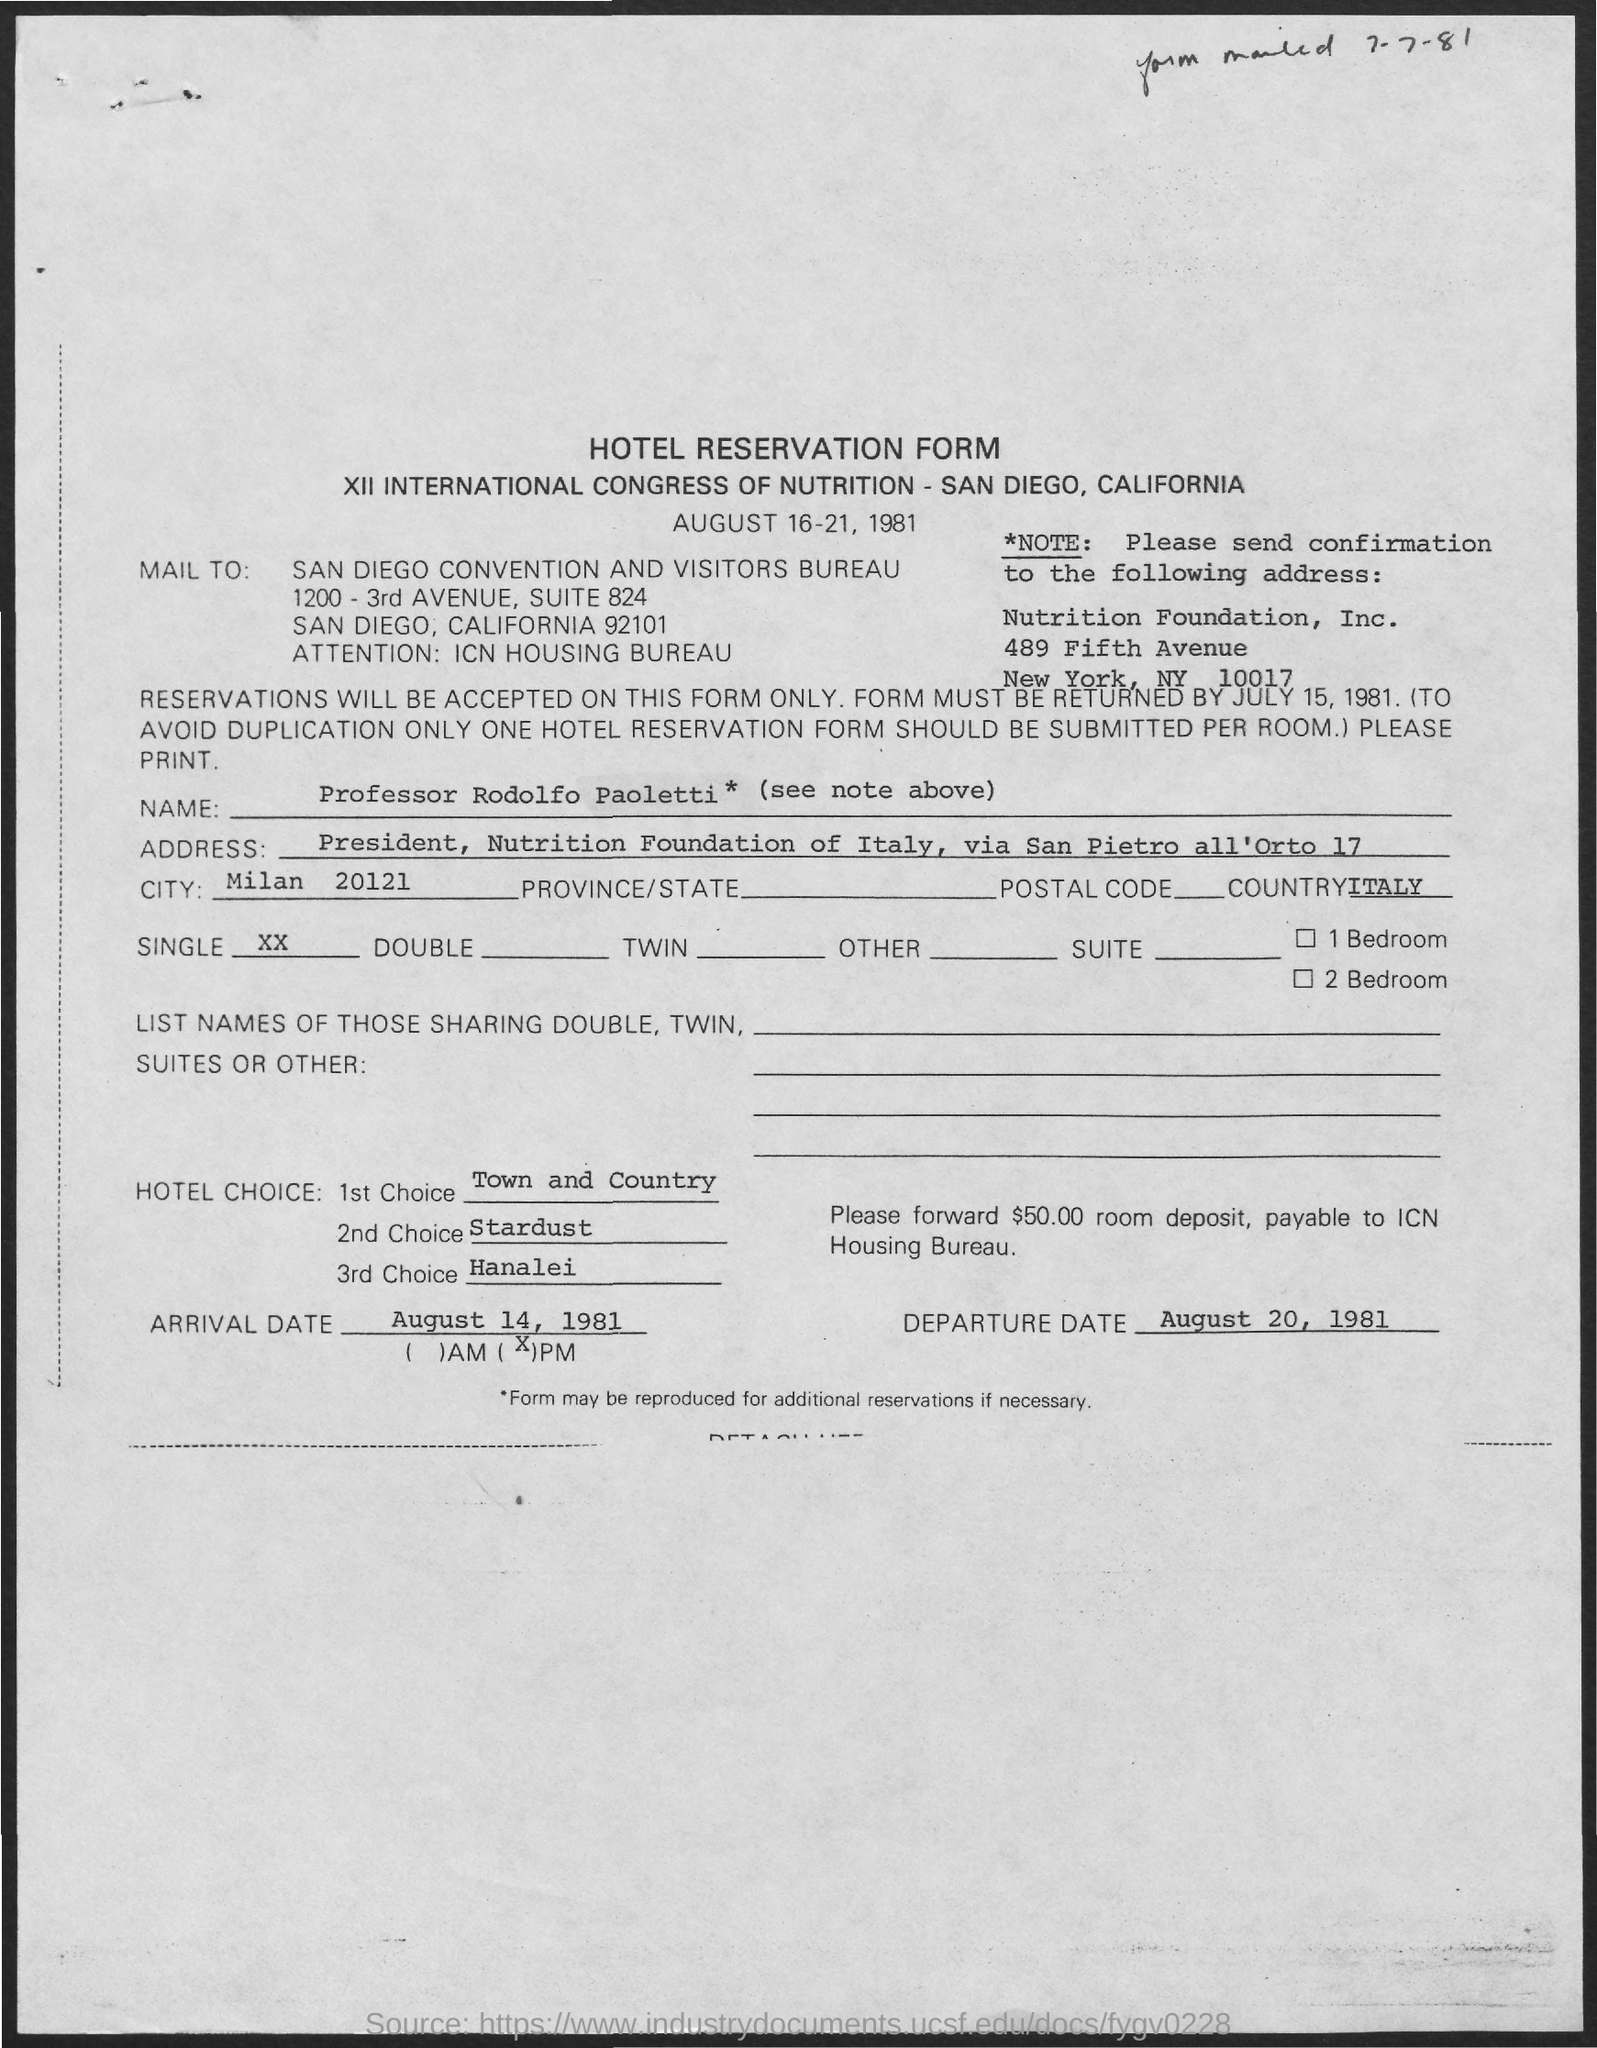Point out several critical features in this image. The recipient of the email is the San Diego Convention and Visitors Bureau. The second hotel choice mentioned in the reservation form is Stardust. The first hotel choice mentioned in the reservation form is Town and Country. The third hotel choice mentioned in the reservation form is Hanalei. The form on the page is a hotel reservation form. 